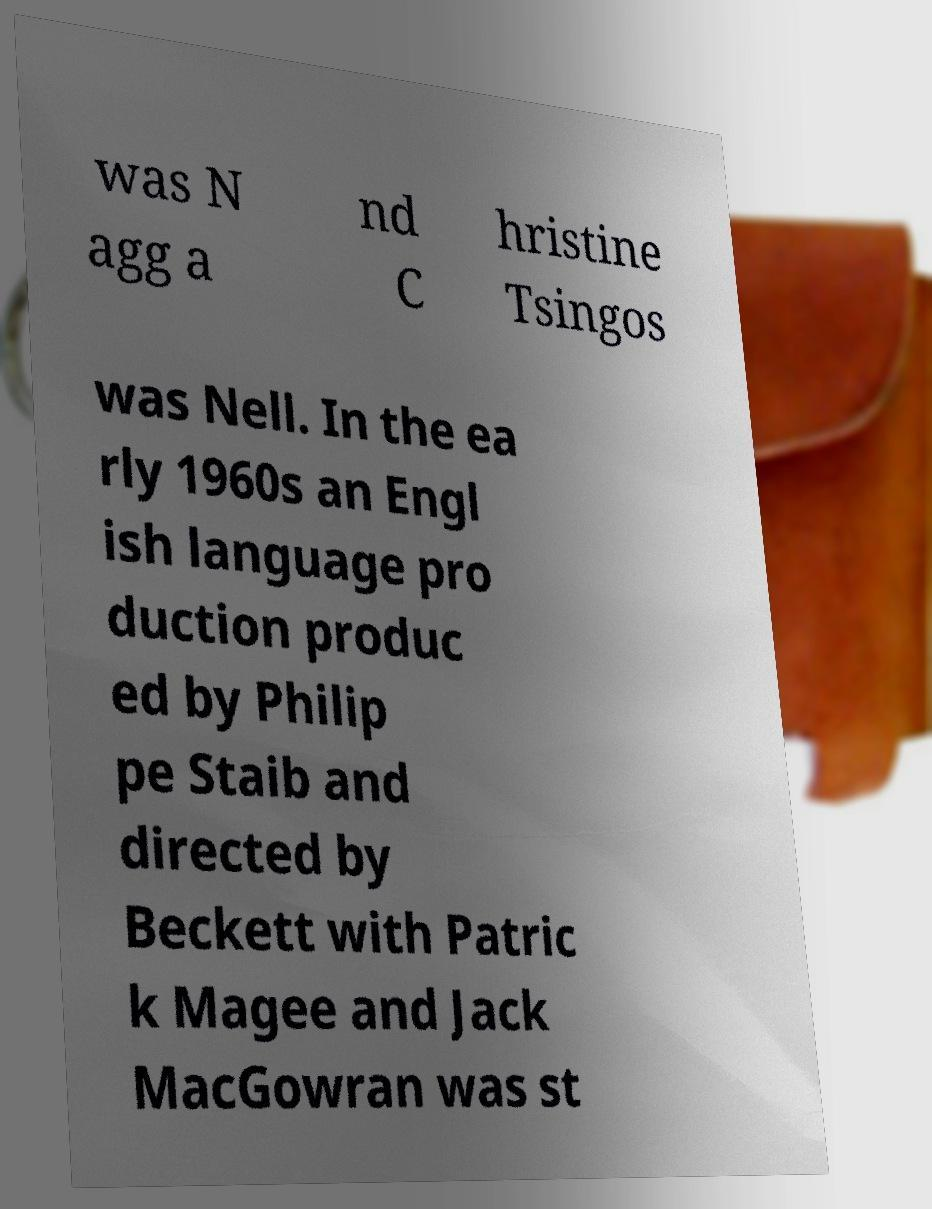Please read and relay the text visible in this image. What does it say? was N agg a nd C hristine Tsingos was Nell. In the ea rly 1960s an Engl ish language pro duction produc ed by Philip pe Staib and directed by Beckett with Patric k Magee and Jack MacGowran was st 